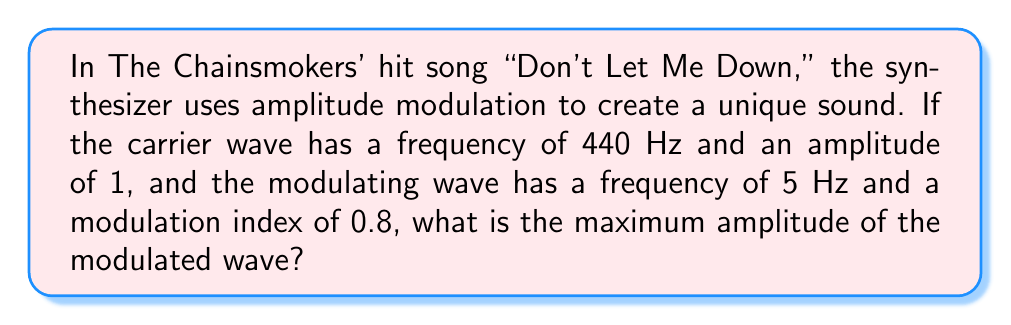Can you solve this math problem? To solve this problem, we need to understand the amplitude modulation formula and apply it to the given parameters. Let's break it down step-by-step:

1. The general equation for amplitude modulation is:
   $$y(t) = A_c[1 + m \sin(2\pi f_m t)] \sin(2\pi f_c t)$$
   where:
   - $A_c$ is the amplitude of the carrier wave
   - $m$ is the modulation index
   - $f_m$ is the frequency of the modulating wave
   - $f_c$ is the frequency of the carrier wave

2. From the question, we have:
   - $A_c = 1$ (amplitude of carrier wave)
   - $m = 0.8$ (modulation index)
   - $f_m = 5$ Hz (frequency of modulating wave)
   - $f_c = 440$ Hz (frequency of carrier wave)

3. The maximum amplitude occurs when the sine terms are at their maximum value of 1. So, we're interested in the maximum value of the term:
   $$A_c[1 + m]$$

4. Substituting our values:
   $$1[1 + 0.8]$$

5. Simplifying:
   $$1 + 0.8 = 1.8$$

Therefore, the maximum amplitude of the modulated wave is 1.8 times the original carrier wave amplitude.
Answer: 1.8 